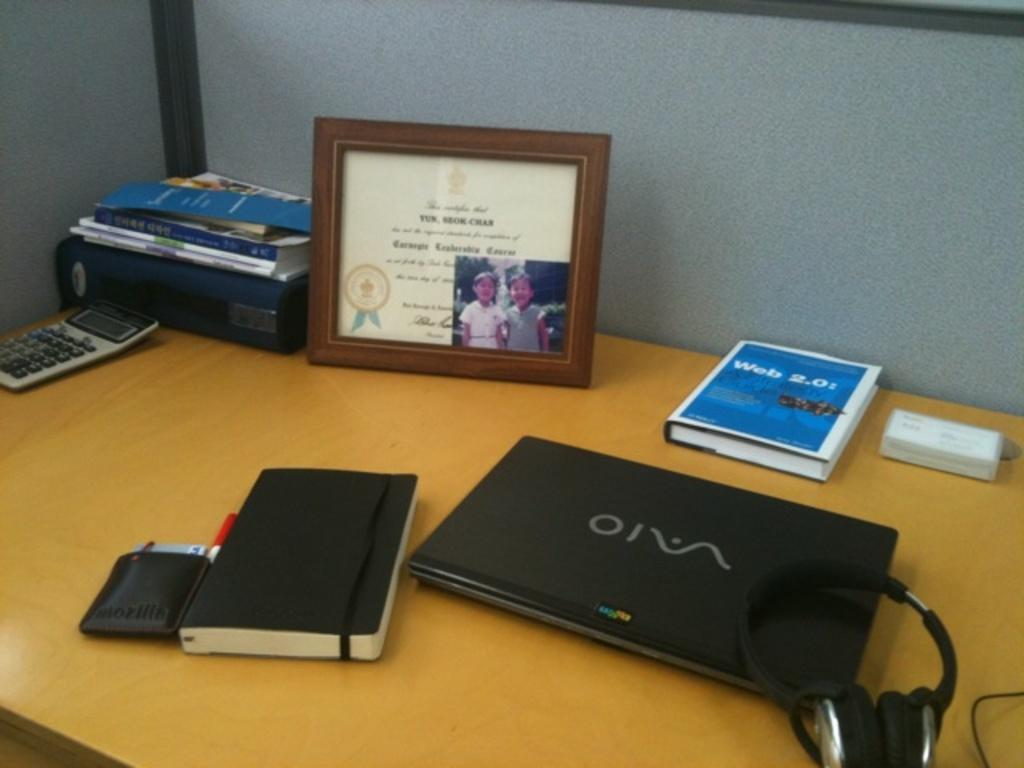What electronic device is visible in the image? There is a laptop in the image. What non-electronic item can be seen in the image? There is a book in the image. What personal item is present in the image? There is a wallet in the image. What tool is used for calculations in the image? There is a calculator in the image. What protective object is featured in the image? There is a shield in the image. What accessory is used for listening in the image? There are headphones in the image. What type of oil is being used to help the flight in the image? There is no oil or flight present in the image; it features a laptop, book, wallet, calculator, shield, and headphones. How does the help arrive in the image? There is no help or indication of assistance arriving in the image. 